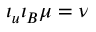<formula> <loc_0><loc_0><loc_500><loc_500>\iota _ { u } \iota _ { B } \mu = \nu</formula> 